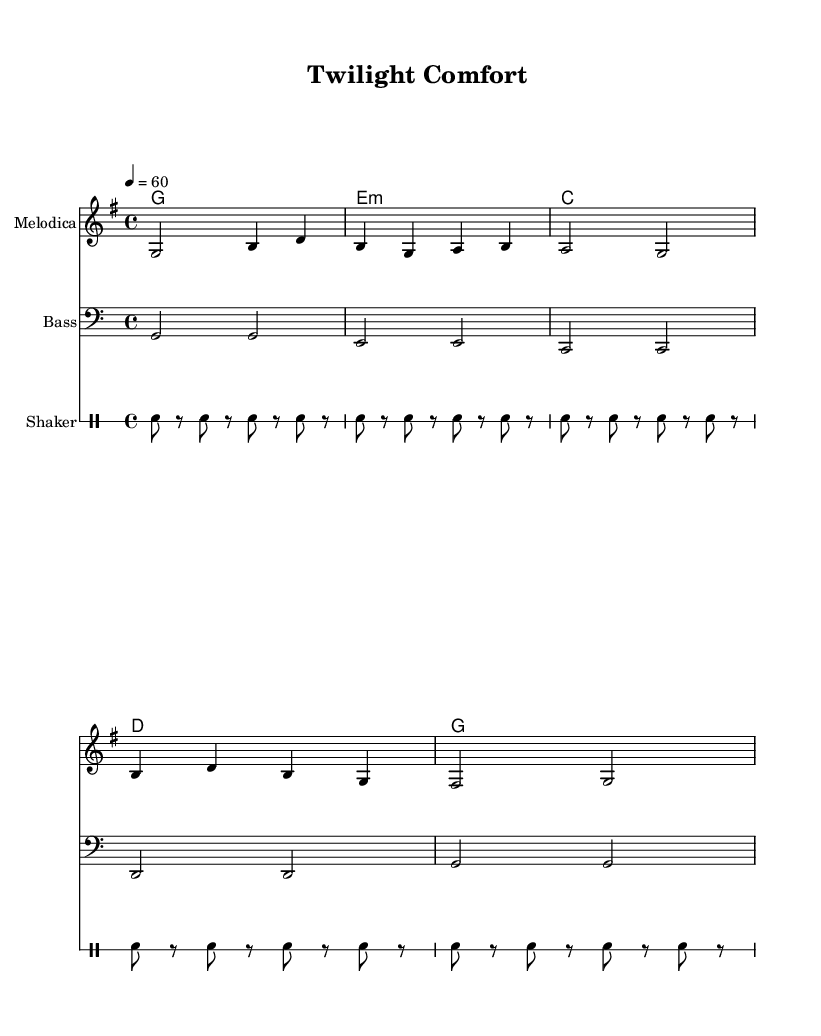What is the key signature of this music? The key signature is G major, which has one sharp (F#). You find the key signature by looking at the beginning of the staff before the notes, where it indicates the sharps and flats for the piece.
Answer: G major What is the time signature of this piece? The time signature is 4/4, indicated at the beginning of the sheet music. It tells you that there are four beats in a measure, and the quarter note gets one beat.
Answer: 4/4 What is the tempo marking for this piece? The tempo marking is 60 beats per minute, shown in the tempo indication at the beginning of the score. It indicates how fast the music should be played, measured in beats per minute.
Answer: 60 How many measures are there in the melody section? The melody section consists of five measures, which can be counted by identifying the vertical lines (bar lines) that separate the measures in the melody staff.
Answer: 5 What instrument is used to play the melody? The melody is played on a Melodica, indicated by the instrument name at the top of the corresponding staff, which is part of the sheet music layout.
Answer: Melodica What type of rhythm does the shaker provide in this piece? The shaker provides a repeating rhythmic pattern, as indicated by the repeated notation in the drummode section. This contributes to the characteristic upbeat feel typical of reggae music.
Answer: Repeating rhythm Is there a specific characteristic of reggae reflected in the harmonies? Yes, the harmonies reflect a simple chord progression, often found in reggae music, which creates a relaxed and soothing atmosphere, essential for lullabies. This can be observed through the selection of basic triads like G, E minor, C, and D.
Answer: Simple chord progression 